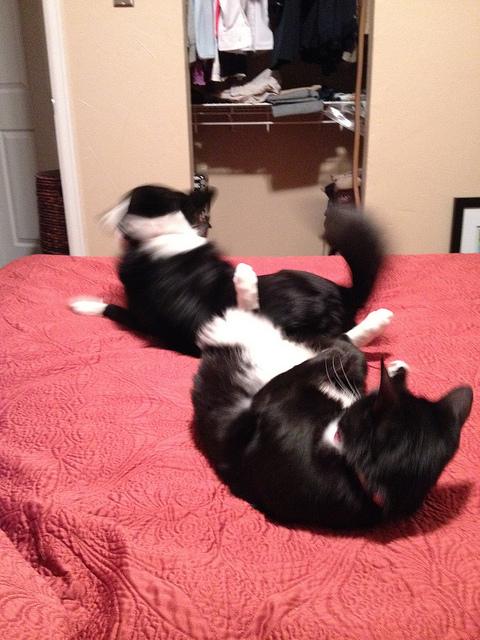What kind of pets are these?
Be succinct. Cats. How many pets are on the bed?
Concise answer only. 2. Are there a cat and dog on this bed?
Quick response, please. Yes. 